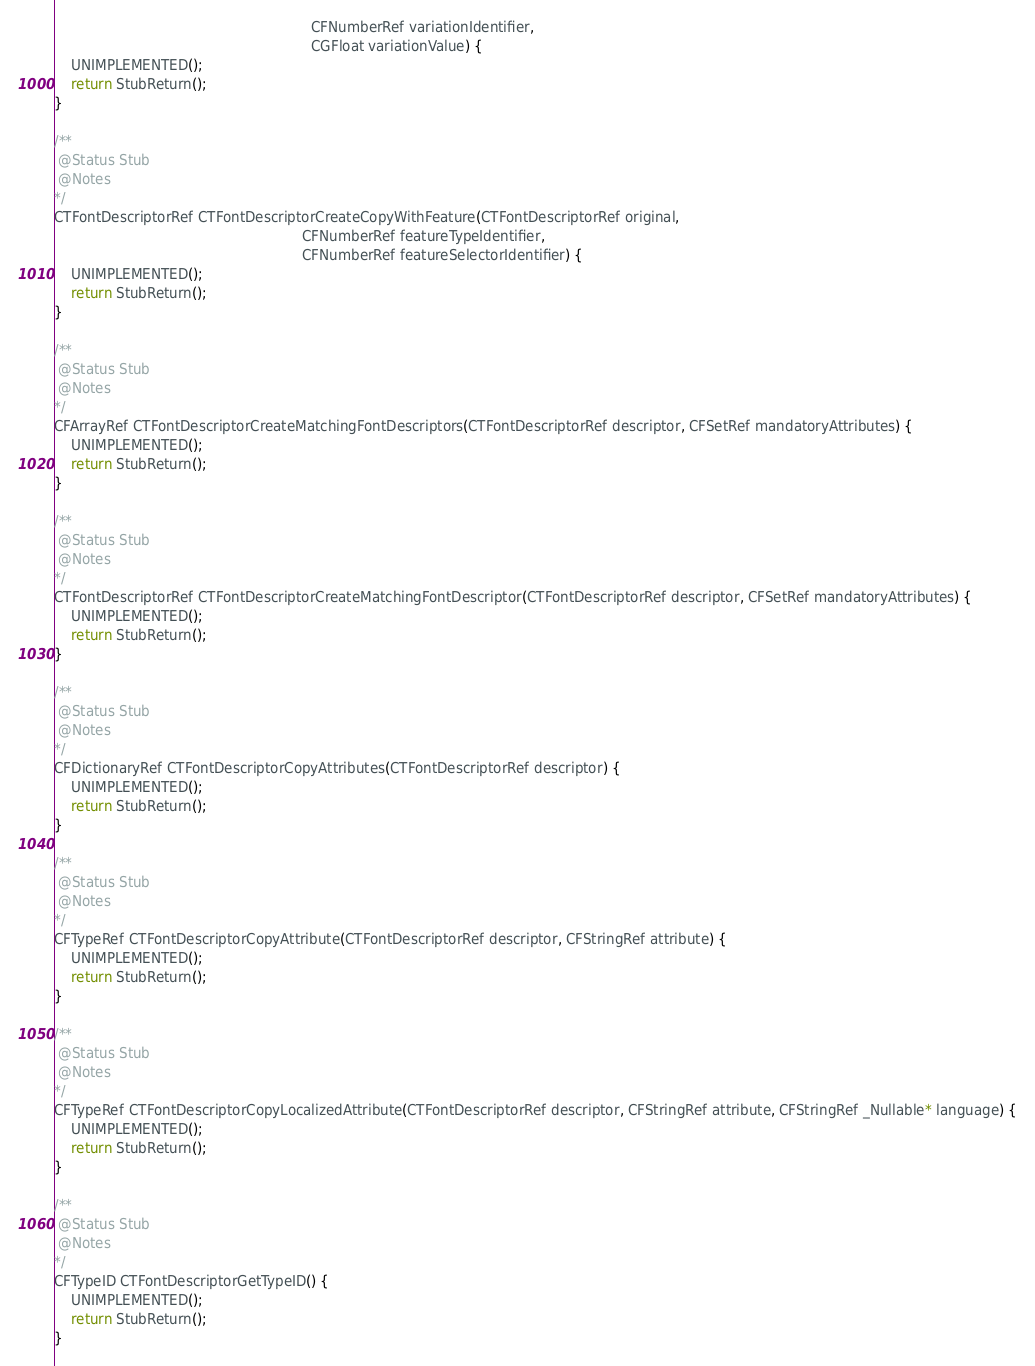<code> <loc_0><loc_0><loc_500><loc_500><_ObjectiveC_>                                                            CFNumberRef variationIdentifier,
                                                            CGFloat variationValue) {
    UNIMPLEMENTED();
    return StubReturn();
}

/**
 @Status Stub
 @Notes
*/
CTFontDescriptorRef CTFontDescriptorCreateCopyWithFeature(CTFontDescriptorRef original,
                                                          CFNumberRef featureTypeIdentifier,
                                                          CFNumberRef featureSelectorIdentifier) {
    UNIMPLEMENTED();
    return StubReturn();
}

/**
 @Status Stub
 @Notes
*/
CFArrayRef CTFontDescriptorCreateMatchingFontDescriptors(CTFontDescriptorRef descriptor, CFSetRef mandatoryAttributes) {
    UNIMPLEMENTED();
    return StubReturn();
}

/**
 @Status Stub
 @Notes
*/
CTFontDescriptorRef CTFontDescriptorCreateMatchingFontDescriptor(CTFontDescriptorRef descriptor, CFSetRef mandatoryAttributes) {
    UNIMPLEMENTED();
    return StubReturn();
}

/**
 @Status Stub
 @Notes
*/
CFDictionaryRef CTFontDescriptorCopyAttributes(CTFontDescriptorRef descriptor) {
    UNIMPLEMENTED();
    return StubReturn();
}

/**
 @Status Stub
 @Notes
*/
CFTypeRef CTFontDescriptorCopyAttribute(CTFontDescriptorRef descriptor, CFStringRef attribute) {
    UNIMPLEMENTED();
    return StubReturn();
}

/**
 @Status Stub
 @Notes
*/
CFTypeRef CTFontDescriptorCopyLocalizedAttribute(CTFontDescriptorRef descriptor, CFStringRef attribute, CFStringRef _Nullable* language) {
    UNIMPLEMENTED();
    return StubReturn();
}

/**
 @Status Stub
 @Notes
*/
CFTypeID CTFontDescriptorGetTypeID() {
    UNIMPLEMENTED();
    return StubReturn();
}
</code> 